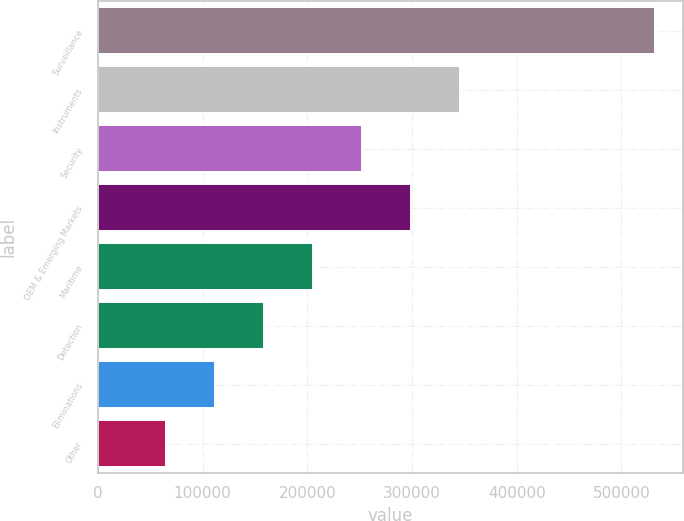Convert chart. <chart><loc_0><loc_0><loc_500><loc_500><bar_chart><fcel>Surveillance<fcel>Instruments<fcel>Security<fcel>OEM & Emerging Markets<fcel>Maritime<fcel>Detection<fcel>Eliminations<fcel>Other<nl><fcel>532476<fcel>345490<fcel>251998<fcel>298744<fcel>205251<fcel>158505<fcel>111758<fcel>65012<nl></chart> 